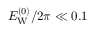<formula> <loc_0><loc_0><loc_500><loc_500>E _ { W } ^ { ( 0 ) } / 2 \pi \ll 0 . 1</formula> 